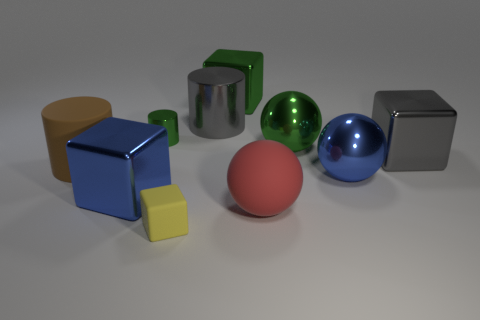Can you describe the differences in textures among the objects? Certainly! In the image, we see a variety of textures. The large blue and silver cubes have a metallic sheen, indicating a smooth and shiny texture. The red and yellow cubes, green cylinder, and large orange cylinder appear to have a matte finish, suggestive of a non-reflective, more diffuse surface texture. Lastly, the green and blue spheres have a glossy finish, which is quite reflective and gives them a lustrous look. 